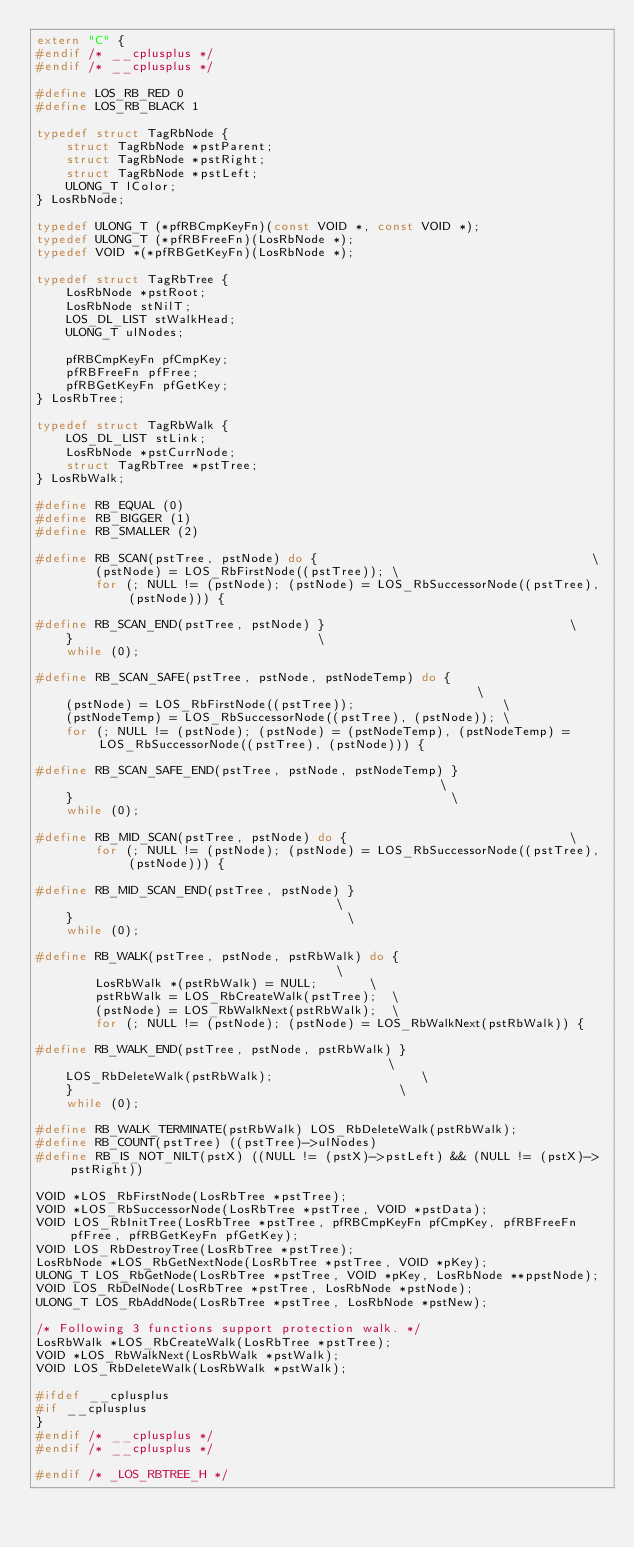<code> <loc_0><loc_0><loc_500><loc_500><_C_>extern "C" {
#endif /* __cplusplus */
#endif /* __cplusplus */

#define LOS_RB_RED 0
#define LOS_RB_BLACK 1

typedef struct TagRbNode {
    struct TagRbNode *pstParent;
    struct TagRbNode *pstRight;
    struct TagRbNode *pstLeft;
    ULONG_T lColor;
} LosRbNode;

typedef ULONG_T (*pfRBCmpKeyFn)(const VOID *, const VOID *);
typedef ULONG_T (*pfRBFreeFn)(LosRbNode *);
typedef VOID *(*pfRBGetKeyFn)(LosRbNode *);

typedef struct TagRbTree {
    LosRbNode *pstRoot;
    LosRbNode stNilT;
    LOS_DL_LIST stWalkHead;
    ULONG_T ulNodes;

    pfRBCmpKeyFn pfCmpKey;
    pfRBFreeFn pfFree;
    pfRBGetKeyFn pfGetKey;
} LosRbTree;

typedef struct TagRbWalk {
    LOS_DL_LIST stLink;
    LosRbNode *pstCurrNode;
    struct TagRbTree *pstTree;
} LosRbWalk;

#define RB_EQUAL (0)
#define RB_BIGGER (1)
#define RB_SMALLER (2)

#define RB_SCAN(pstTree, pstNode) do {                                     \
        (pstNode) = LOS_RbFirstNode((pstTree)); \
        for (; NULL != (pstNode); (pstNode) = LOS_RbSuccessorNode((pstTree), (pstNode))) {

#define RB_SCAN_END(pstTree, pstNode) }                                 \
    }                                 \
    while (0);

#define RB_SCAN_SAFE(pstTree, pstNode, pstNodeTemp) do {                                                        \
    (pstNode) = LOS_RbFirstNode((pstTree));                    \
    (pstNodeTemp) = LOS_RbSuccessorNode((pstTree), (pstNode)); \
    for (; NULL != (pstNode); (pstNode) = (pstNodeTemp), (pstNodeTemp) = LOS_RbSuccessorNode((pstTree), (pstNode))) {

#define RB_SCAN_SAFE_END(pstTree, pstNode, pstNodeTemp) }                                                   \
    }                                                   \
    while (0);

#define RB_MID_SCAN(pstTree, pstNode) do {                              \
        for (; NULL != (pstNode); (pstNode) = LOS_RbSuccessorNode((pstTree), (pstNode))) {

#define RB_MID_SCAN_END(pstTree, pstNode) }                                     \
    }                                     \
    while (0);

#define RB_WALK(pstTree, pstNode, pstRbWalk) do {                                     \
        LosRbWalk *(pstRbWalk) = NULL;       \
        pstRbWalk = LOS_RbCreateWalk(pstTree);  \
        (pstNode) = LOS_RbWalkNext(pstRbWalk);  \
        for (; NULL != (pstNode); (pstNode) = LOS_RbWalkNext(pstRbWalk)) {

#define RB_WALK_END(pstTree, pstNode, pstRbWalk) }                                            \
    LOS_RbDeleteWalk(pstRbWalk);                    \
    }                                            \
    while (0);

#define RB_WALK_TERMINATE(pstRbWalk) LOS_RbDeleteWalk(pstRbWalk);
#define RB_COUNT(pstTree) ((pstTree)->ulNodes)
#define RB_IS_NOT_NILT(pstX) ((NULL != (pstX)->pstLeft) && (NULL != (pstX)->pstRight))

VOID *LOS_RbFirstNode(LosRbTree *pstTree);
VOID *LOS_RbSuccessorNode(LosRbTree *pstTree, VOID *pstData);
VOID LOS_RbInitTree(LosRbTree *pstTree, pfRBCmpKeyFn pfCmpKey, pfRBFreeFn pfFree, pfRBGetKeyFn pfGetKey);
VOID LOS_RbDestroyTree(LosRbTree *pstTree);
LosRbNode *LOS_RbGetNextNode(LosRbTree *pstTree, VOID *pKey);
ULONG_T LOS_RbGetNode(LosRbTree *pstTree, VOID *pKey, LosRbNode **ppstNode);
VOID LOS_RbDelNode(LosRbTree *pstTree, LosRbNode *pstNode);
ULONG_T LOS_RbAddNode(LosRbTree *pstTree, LosRbNode *pstNew);

/* Following 3 functions support protection walk. */
LosRbWalk *LOS_RbCreateWalk(LosRbTree *pstTree);
VOID *LOS_RbWalkNext(LosRbWalk *pstWalk);
VOID LOS_RbDeleteWalk(LosRbWalk *pstWalk);

#ifdef __cplusplus
#if __cplusplus
}
#endif /* __cplusplus */
#endif /* __cplusplus */

#endif /* _LOS_RBTREE_H */
</code> 